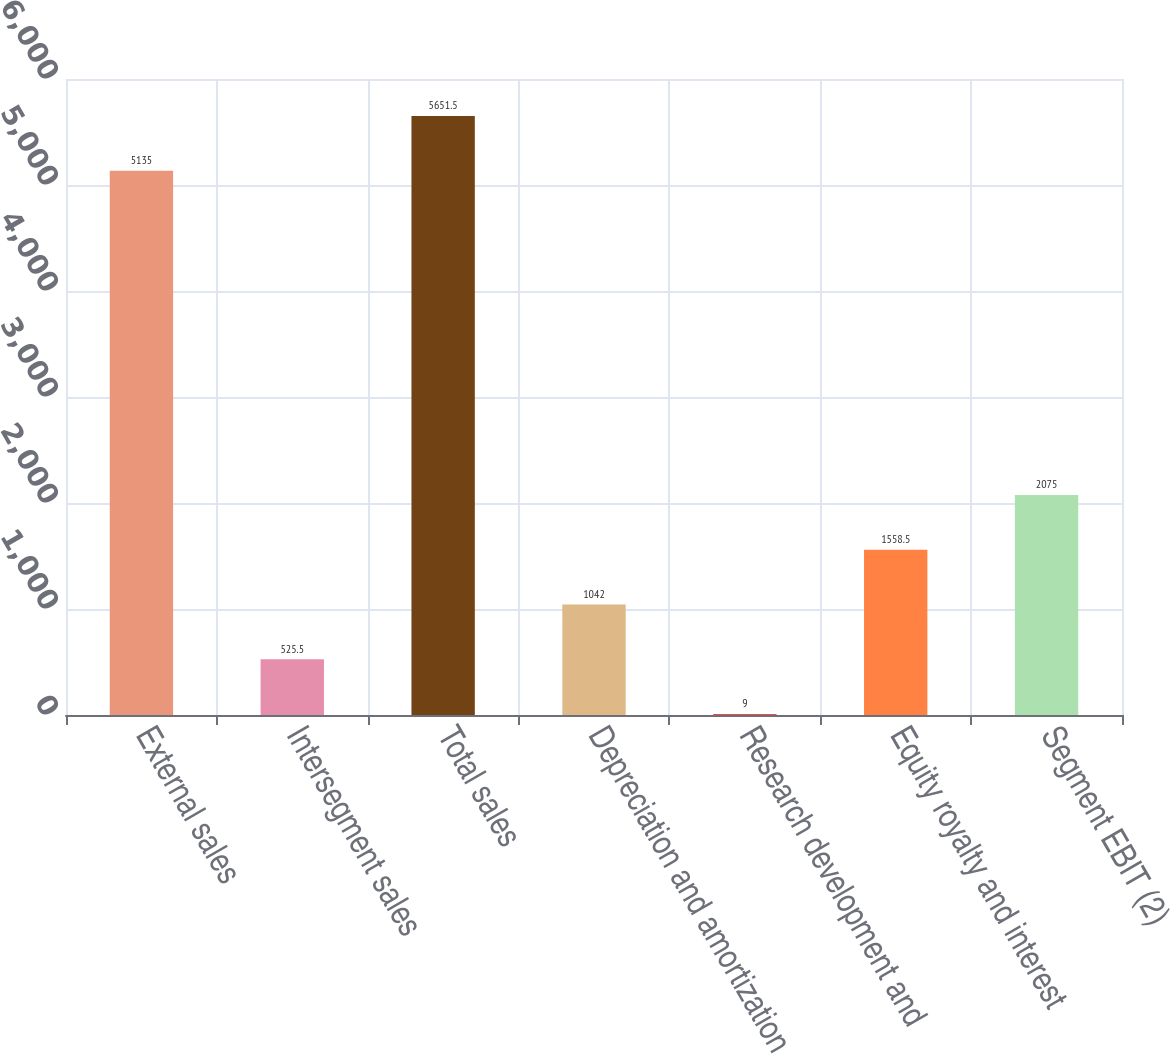Convert chart to OTSL. <chart><loc_0><loc_0><loc_500><loc_500><bar_chart><fcel>External sales<fcel>Intersegment sales<fcel>Total sales<fcel>Depreciation and amortization<fcel>Research development and<fcel>Equity royalty and interest<fcel>Segment EBIT (2)<nl><fcel>5135<fcel>525.5<fcel>5651.5<fcel>1042<fcel>9<fcel>1558.5<fcel>2075<nl></chart> 